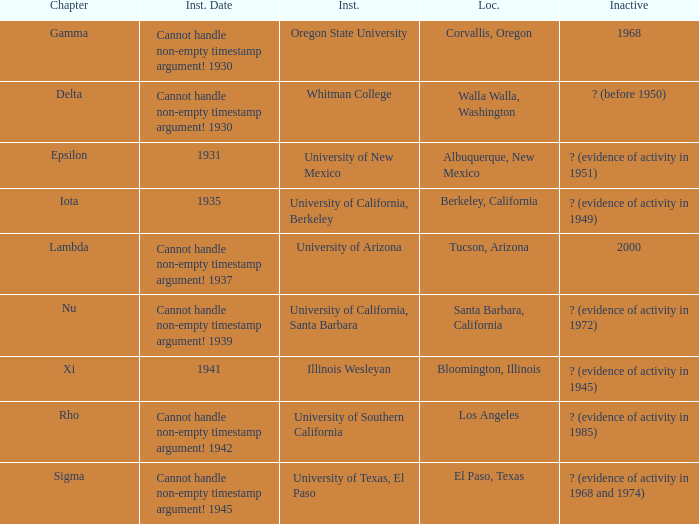Can you parse all the data within this table? {'header': ['Chapter', 'Inst. Date', 'Inst.', 'Loc.', 'Inactive'], 'rows': [['Gamma', 'Cannot handle non-empty timestamp argument! 1930', 'Oregon State University', 'Corvallis, Oregon', '1968'], ['Delta', 'Cannot handle non-empty timestamp argument! 1930', 'Whitman College', 'Walla Walla, Washington', '? (before 1950)'], ['Epsilon', '1931', 'University of New Mexico', 'Albuquerque, New Mexico', '? (evidence of activity in 1951)'], ['Iota', '1935', 'University of California, Berkeley', 'Berkeley, California', '? (evidence of activity in 1949)'], ['Lambda', 'Cannot handle non-empty timestamp argument! 1937', 'University of Arizona', 'Tucson, Arizona', '2000'], ['Nu', 'Cannot handle non-empty timestamp argument! 1939', 'University of California, Santa Barbara', 'Santa Barbara, California', '? (evidence of activity in 1972)'], ['Xi', '1941', 'Illinois Wesleyan', 'Bloomington, Illinois', '? (evidence of activity in 1945)'], ['Rho', 'Cannot handle non-empty timestamp argument! 1942', 'University of Southern California', 'Los Angeles', '? (evidence of activity in 1985)'], ['Sigma', 'Cannot handle non-empty timestamp argument! 1945', 'University of Texas, El Paso', 'El Paso, Texas', '? (evidence of activity in 1968 and 1974)']]} What does the inactive state for University of Texas, El Paso?  ? (evidence of activity in 1968 and 1974). 